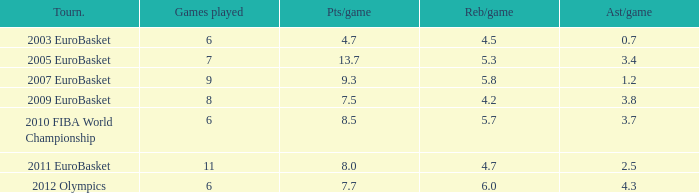How many assists per game have 4.2 rebounds per game? 3.8. 